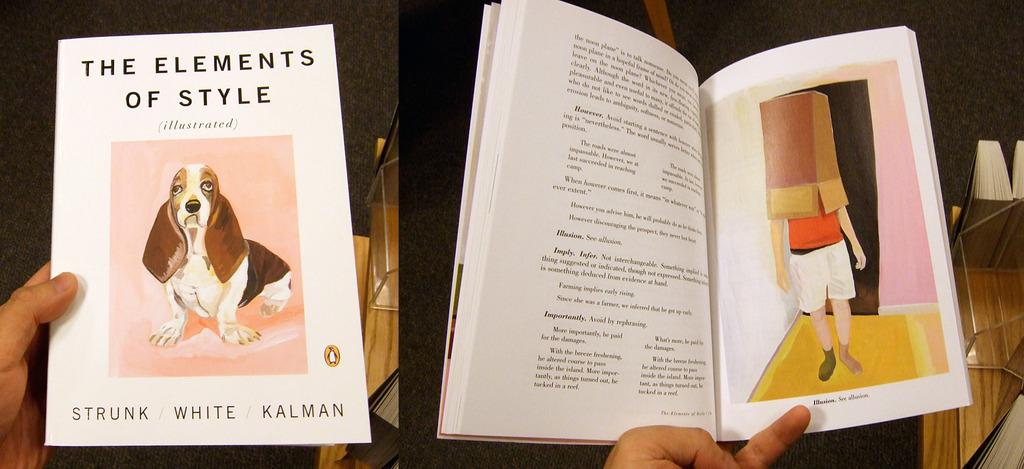What is the main subject of the image? The image contains a collage of two pictures. What is happening in the first picture? In the first picture, a person's hands are holding books. What can be seen on the cover page of a book in the image? The cover page of a book is visible in the image. What is featured in the second picture of the collage? An open book with an image and text is present in the image. Are there any structures visible in the image? There is no mention of any structures in the image; it primarily features books and a collage. Can you see any giants or ghosts in the image? No, there are no giants or ghosts present in the image. 